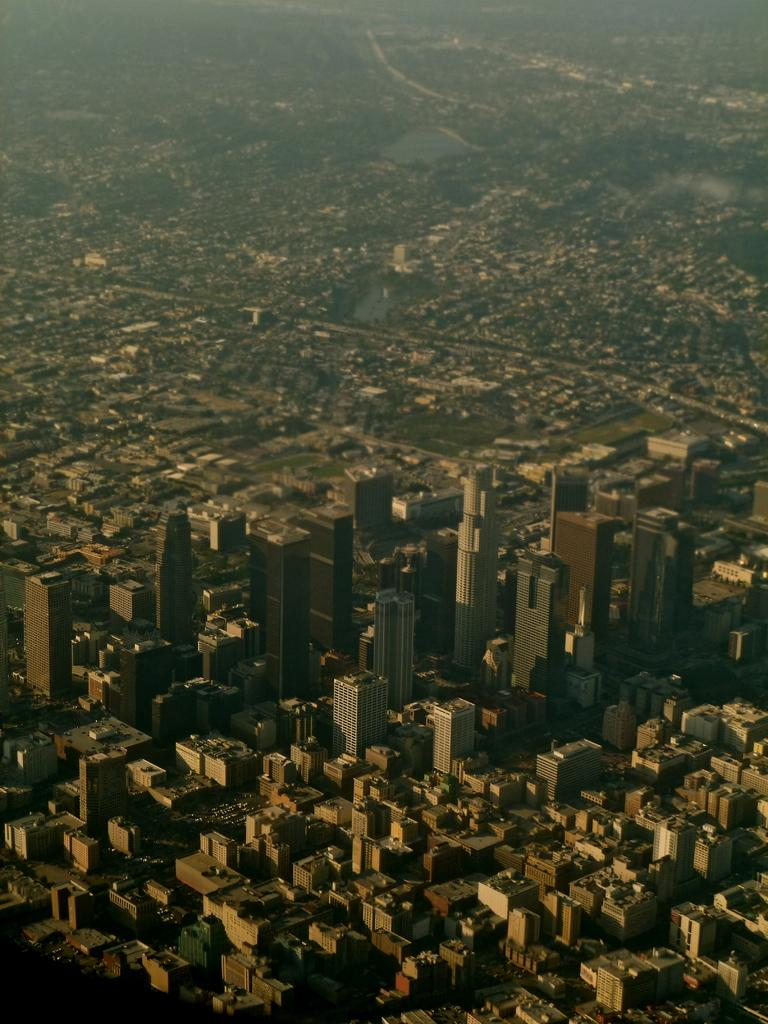What type of view is shown in the image? The image is an aerial view. What can be seen at the bottom of the picture? There are buildings at the bottom of the picture. What natural elements are visible in the image? Water bodies and trees are present in the image. What type of structures are featured in the image? Buildings are present in the image. What type of hat is the writer wearing in the image? There is no writer or hat present in the image. 